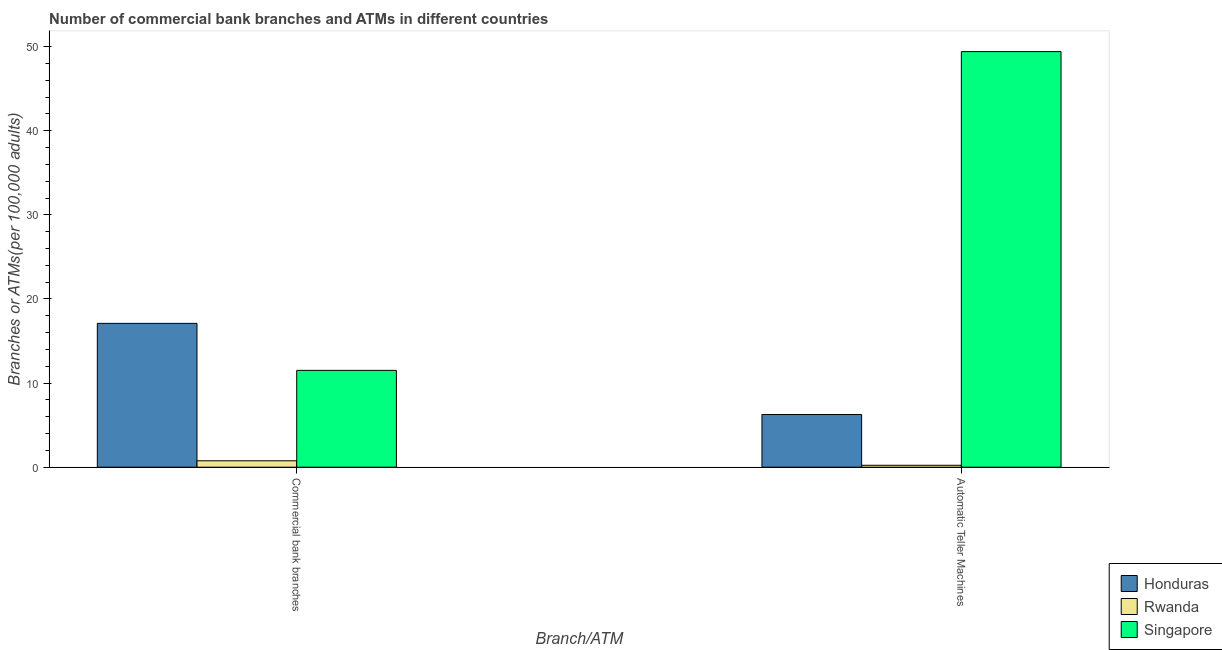How many groups of bars are there?
Your answer should be very brief. 2. How many bars are there on the 2nd tick from the left?
Make the answer very short. 3. What is the label of the 1st group of bars from the left?
Your answer should be very brief. Commercial bank branches. What is the number of commercal bank branches in Honduras?
Give a very brief answer. 17.1. Across all countries, what is the maximum number of commercal bank branches?
Give a very brief answer. 17.1. Across all countries, what is the minimum number of atms?
Provide a short and direct response. 0.23. In which country was the number of commercal bank branches maximum?
Your answer should be compact. Honduras. In which country was the number of commercal bank branches minimum?
Keep it short and to the point. Rwanda. What is the total number of commercal bank branches in the graph?
Your answer should be very brief. 29.37. What is the difference between the number of commercal bank branches in Singapore and that in Rwanda?
Give a very brief answer. 10.75. What is the difference between the number of atms in Rwanda and the number of commercal bank branches in Honduras?
Make the answer very short. -16.87. What is the average number of atms per country?
Keep it short and to the point. 18.63. What is the difference between the number of commercal bank branches and number of atms in Honduras?
Your answer should be very brief. 10.84. What is the ratio of the number of commercal bank branches in Rwanda to that in Singapore?
Keep it short and to the point. 0.07. Is the number of commercal bank branches in Singapore less than that in Honduras?
Your answer should be very brief. Yes. In how many countries, is the number of atms greater than the average number of atms taken over all countries?
Your response must be concise. 1. What does the 3rd bar from the left in Commercial bank branches represents?
Your response must be concise. Singapore. What does the 1st bar from the right in Automatic Teller Machines represents?
Your answer should be compact. Singapore. Are all the bars in the graph horizontal?
Make the answer very short. No. What is the difference between two consecutive major ticks on the Y-axis?
Offer a terse response. 10. Are the values on the major ticks of Y-axis written in scientific E-notation?
Provide a short and direct response. No. Does the graph contain any zero values?
Your response must be concise. No. Where does the legend appear in the graph?
Your answer should be very brief. Bottom right. How are the legend labels stacked?
Your answer should be very brief. Vertical. What is the title of the graph?
Ensure brevity in your answer.  Number of commercial bank branches and ATMs in different countries. What is the label or title of the X-axis?
Provide a short and direct response. Branch/ATM. What is the label or title of the Y-axis?
Provide a succinct answer. Branches or ATMs(per 100,0 adults). What is the Branches or ATMs(per 100,000 adults) of Honduras in Commercial bank branches?
Provide a short and direct response. 17.1. What is the Branches or ATMs(per 100,000 adults) in Rwanda in Commercial bank branches?
Provide a succinct answer. 0.76. What is the Branches or ATMs(per 100,000 adults) in Singapore in Commercial bank branches?
Make the answer very short. 11.51. What is the Branches or ATMs(per 100,000 adults) of Honduras in Automatic Teller Machines?
Provide a short and direct response. 6.26. What is the Branches or ATMs(per 100,000 adults) in Rwanda in Automatic Teller Machines?
Your answer should be very brief. 0.23. What is the Branches or ATMs(per 100,000 adults) of Singapore in Automatic Teller Machines?
Offer a very short reply. 49.41. Across all Branch/ATM, what is the maximum Branches or ATMs(per 100,000 adults) in Honduras?
Make the answer very short. 17.1. Across all Branch/ATM, what is the maximum Branches or ATMs(per 100,000 adults) of Rwanda?
Make the answer very short. 0.76. Across all Branch/ATM, what is the maximum Branches or ATMs(per 100,000 adults) of Singapore?
Offer a terse response. 49.41. Across all Branch/ATM, what is the minimum Branches or ATMs(per 100,000 adults) in Honduras?
Provide a short and direct response. 6.26. Across all Branch/ATM, what is the minimum Branches or ATMs(per 100,000 adults) in Rwanda?
Make the answer very short. 0.23. Across all Branch/ATM, what is the minimum Branches or ATMs(per 100,000 adults) in Singapore?
Your answer should be very brief. 11.51. What is the total Branches or ATMs(per 100,000 adults) in Honduras in the graph?
Keep it short and to the point. 23.36. What is the total Branches or ATMs(per 100,000 adults) in Rwanda in the graph?
Make the answer very short. 0.99. What is the total Branches or ATMs(per 100,000 adults) of Singapore in the graph?
Your answer should be very brief. 60.92. What is the difference between the Branches or ATMs(per 100,000 adults) of Honduras in Commercial bank branches and that in Automatic Teller Machines?
Keep it short and to the point. 10.84. What is the difference between the Branches or ATMs(per 100,000 adults) of Rwanda in Commercial bank branches and that in Automatic Teller Machines?
Give a very brief answer. 0.53. What is the difference between the Branches or ATMs(per 100,000 adults) of Singapore in Commercial bank branches and that in Automatic Teller Machines?
Offer a terse response. -37.9. What is the difference between the Branches or ATMs(per 100,000 adults) of Honduras in Commercial bank branches and the Branches or ATMs(per 100,000 adults) of Rwanda in Automatic Teller Machines?
Keep it short and to the point. 16.87. What is the difference between the Branches or ATMs(per 100,000 adults) of Honduras in Commercial bank branches and the Branches or ATMs(per 100,000 adults) of Singapore in Automatic Teller Machines?
Your answer should be compact. -32.31. What is the difference between the Branches or ATMs(per 100,000 adults) in Rwanda in Commercial bank branches and the Branches or ATMs(per 100,000 adults) in Singapore in Automatic Teller Machines?
Offer a terse response. -48.65. What is the average Branches or ATMs(per 100,000 adults) of Honduras per Branch/ATM?
Provide a short and direct response. 11.68. What is the average Branches or ATMs(per 100,000 adults) of Rwanda per Branch/ATM?
Your answer should be compact. 0.49. What is the average Branches or ATMs(per 100,000 adults) in Singapore per Branch/ATM?
Give a very brief answer. 30.46. What is the difference between the Branches or ATMs(per 100,000 adults) in Honduras and Branches or ATMs(per 100,000 adults) in Rwanda in Commercial bank branches?
Provide a short and direct response. 16.34. What is the difference between the Branches or ATMs(per 100,000 adults) of Honduras and Branches or ATMs(per 100,000 adults) of Singapore in Commercial bank branches?
Provide a short and direct response. 5.59. What is the difference between the Branches or ATMs(per 100,000 adults) of Rwanda and Branches or ATMs(per 100,000 adults) of Singapore in Commercial bank branches?
Ensure brevity in your answer.  -10.75. What is the difference between the Branches or ATMs(per 100,000 adults) of Honduras and Branches or ATMs(per 100,000 adults) of Rwanda in Automatic Teller Machines?
Offer a terse response. 6.03. What is the difference between the Branches or ATMs(per 100,000 adults) in Honduras and Branches or ATMs(per 100,000 adults) in Singapore in Automatic Teller Machines?
Your answer should be very brief. -43.15. What is the difference between the Branches or ATMs(per 100,000 adults) in Rwanda and Branches or ATMs(per 100,000 adults) in Singapore in Automatic Teller Machines?
Give a very brief answer. -49.18. What is the ratio of the Branches or ATMs(per 100,000 adults) in Honduras in Commercial bank branches to that in Automatic Teller Machines?
Ensure brevity in your answer.  2.73. What is the ratio of the Branches or ATMs(per 100,000 adults) of Singapore in Commercial bank branches to that in Automatic Teller Machines?
Your answer should be compact. 0.23. What is the difference between the highest and the second highest Branches or ATMs(per 100,000 adults) in Honduras?
Provide a short and direct response. 10.84. What is the difference between the highest and the second highest Branches or ATMs(per 100,000 adults) in Rwanda?
Make the answer very short. 0.53. What is the difference between the highest and the second highest Branches or ATMs(per 100,000 adults) in Singapore?
Ensure brevity in your answer.  37.9. What is the difference between the highest and the lowest Branches or ATMs(per 100,000 adults) in Honduras?
Ensure brevity in your answer.  10.84. What is the difference between the highest and the lowest Branches or ATMs(per 100,000 adults) in Rwanda?
Give a very brief answer. 0.53. What is the difference between the highest and the lowest Branches or ATMs(per 100,000 adults) in Singapore?
Offer a terse response. 37.9. 